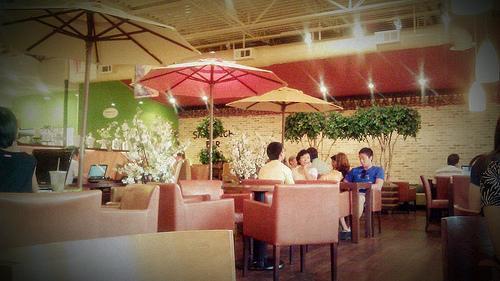How many people are wearing a blue shirt?
Give a very brief answer. 1. How many umbrellas are there?
Give a very brief answer. 3. 